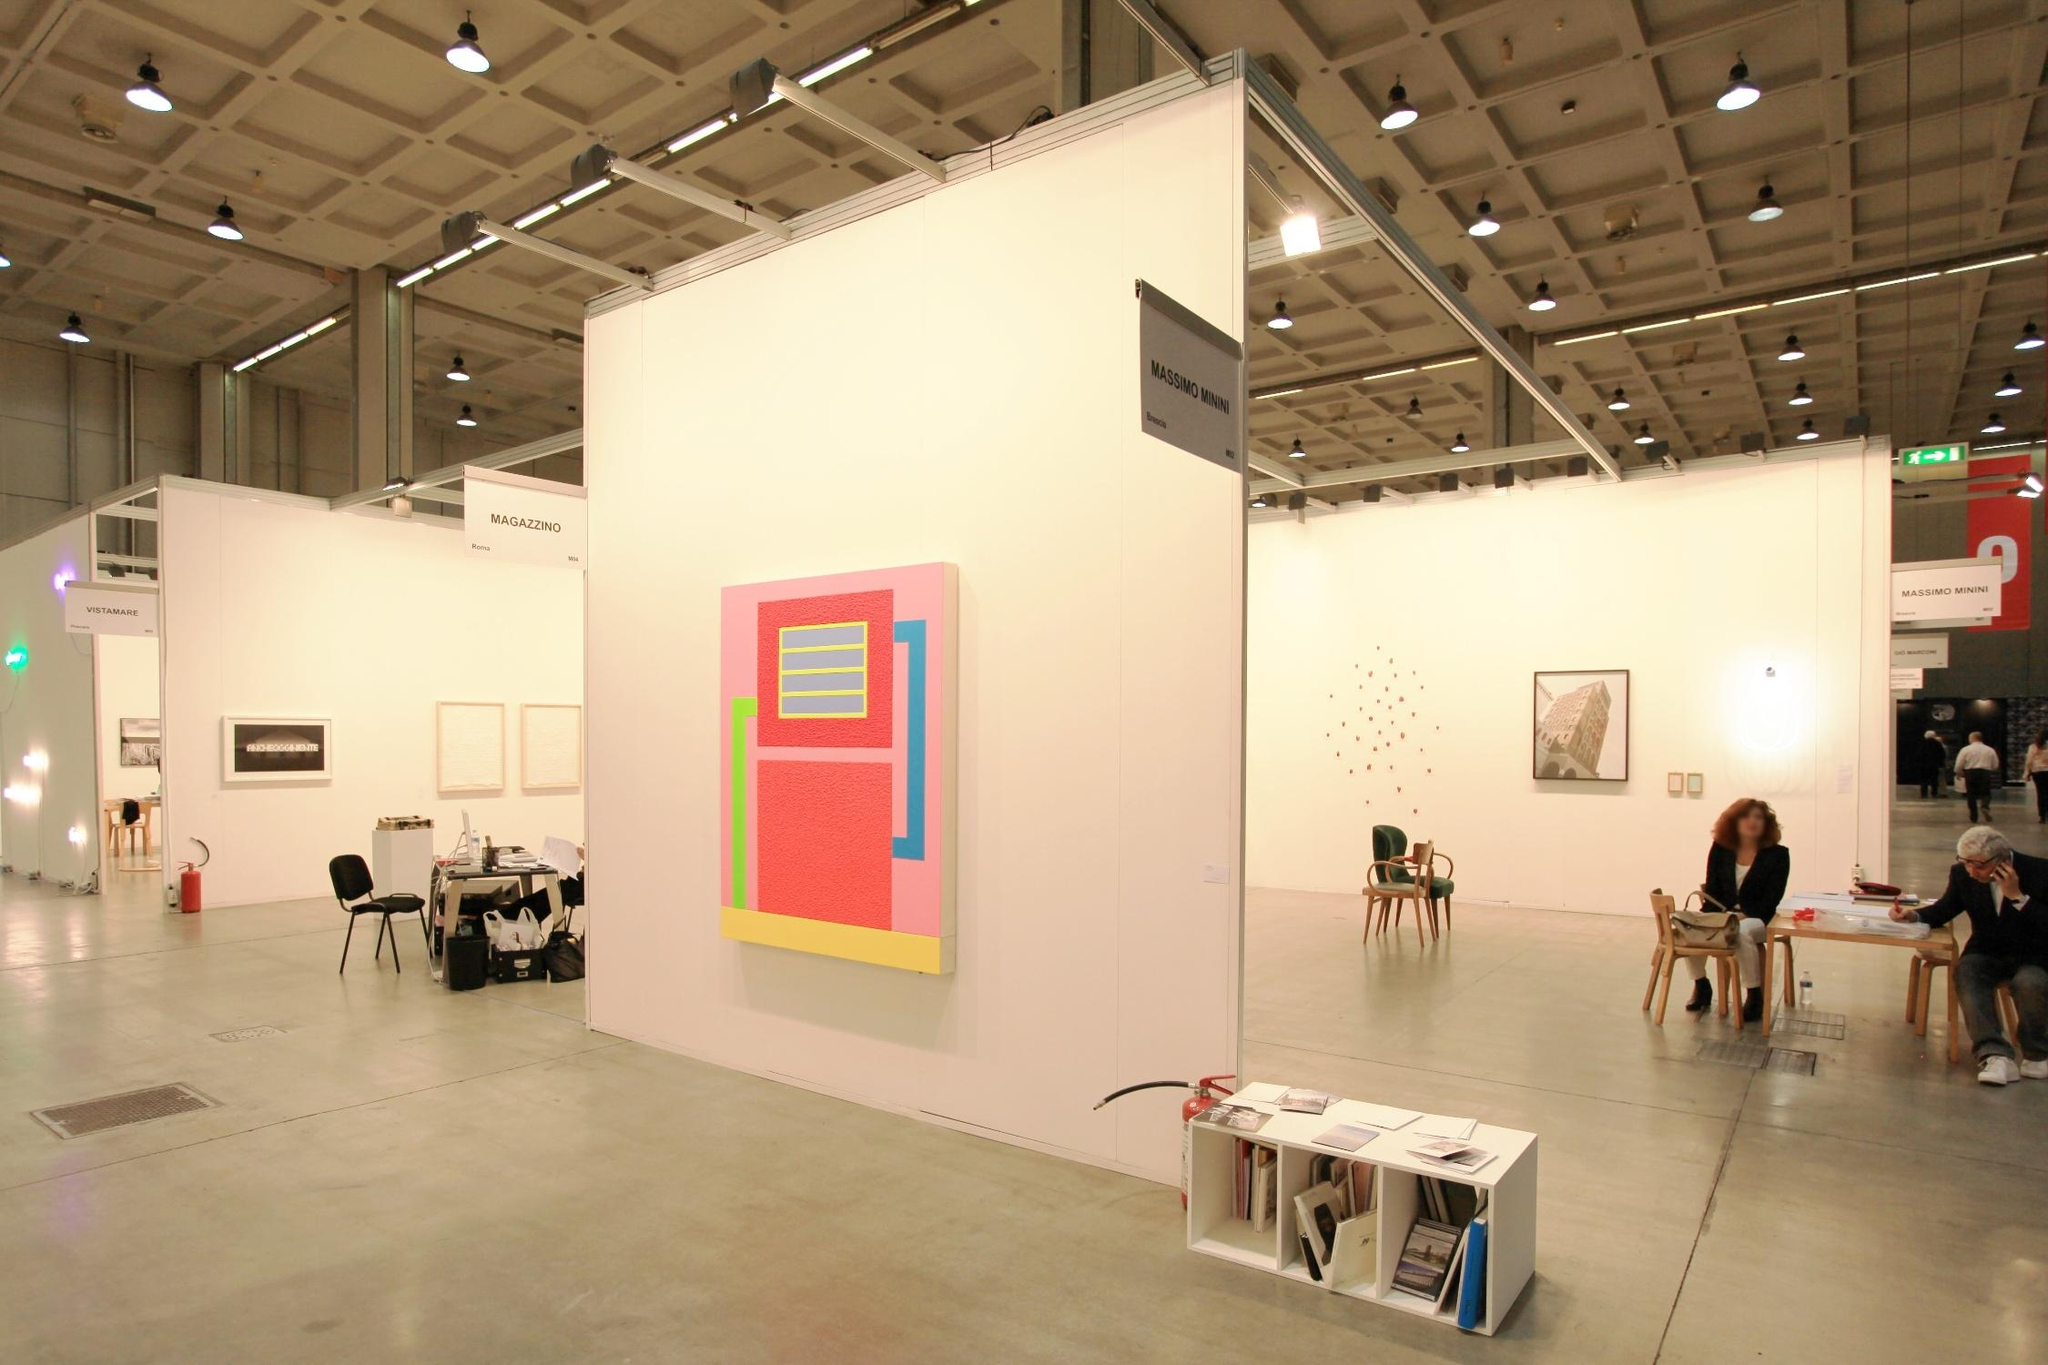Write a detailed description of the given image. The image showcases an art exhibition in a spacious gallery with high ceilings and concrete flooring. The main focus is a large, geometric abstract painting displayed on a white wall. The painting features a vibrant pink background with a central design of a yellow and blue rectangle. In the background, other artworks and visitors to the exhibition can be seen, adding a lively atmosphere to the scene. In the foreground, a table with books and brochures provides additional context to the displayed artworks. The overall scene captures the essence of a modern art exhibition, inviting viewers to explore and interpret the various pieces on display. Please note that the information about the landmark "sa_17414" could not be found in my current knowledge base. 